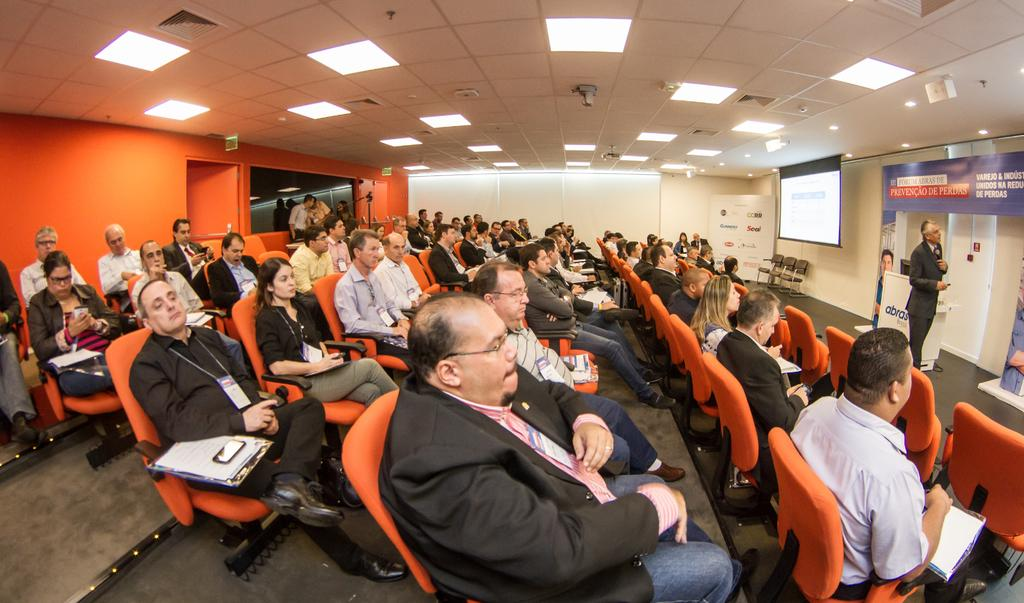What are the people in the image doing? The people in the image are sitting on chairs. Can you describe the lighting in the image? There are lights visible at the top of the image. What type of elbow can be seen in the image? There is no elbow present in the image. What kind of cemetery is visible in the image? There is no cemetery present in the image. 